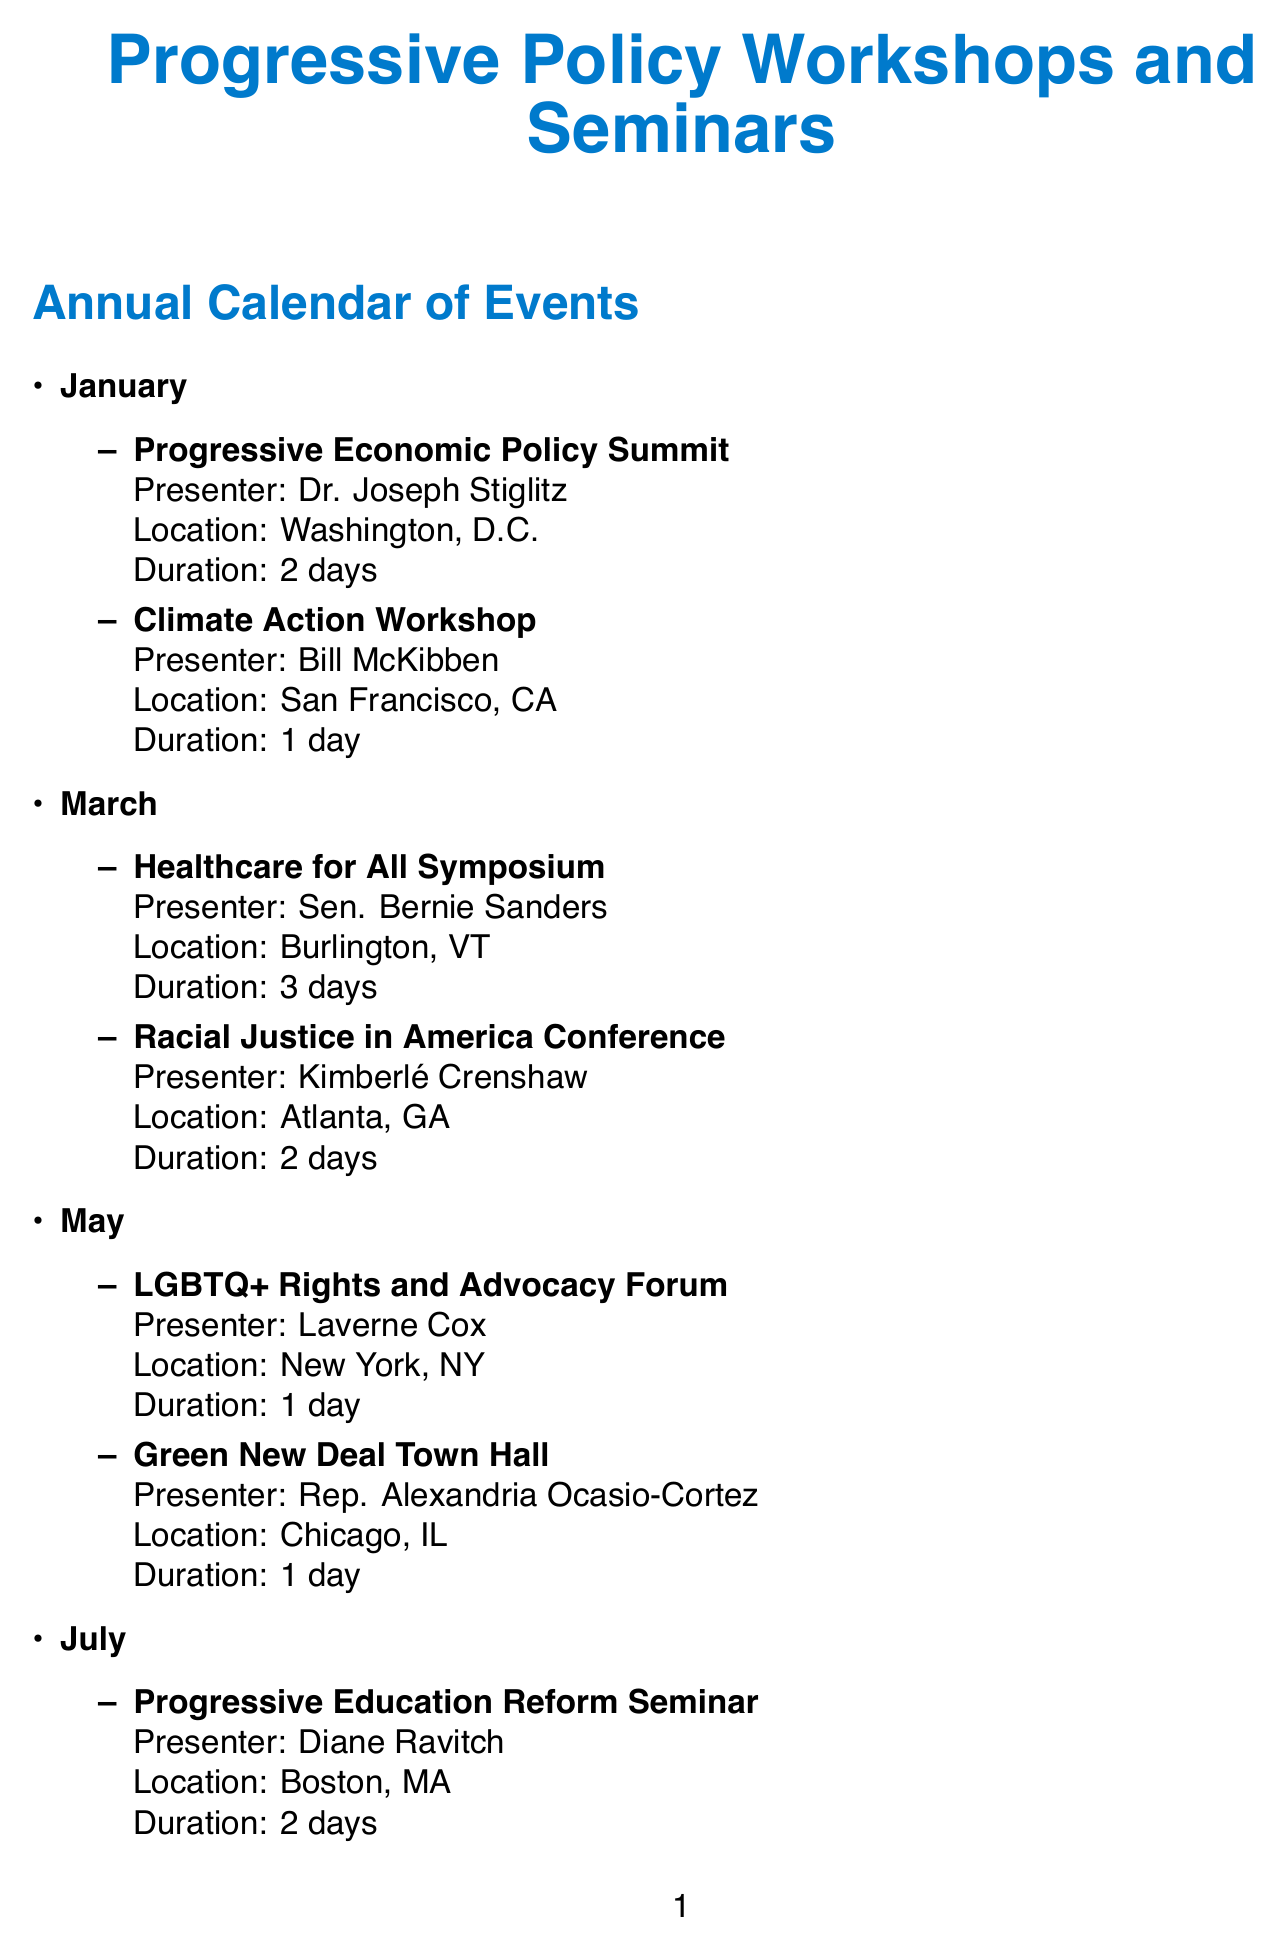What is the name of the presenter for the Climate Action Workshop? The information can be found under the January events section, specifically for the Climate Action Workshop.
Answer: Bill McKibben How long is the Healthcare for All Symposium? This information is provided in the March events listing, detailing the duration of the symposium.
Answer: 3 days Which city hosts the Intersectional Feminism and Gender Equality Summit? This location is specified in the November events section for the Intersectional Feminism and Gender Equality Summit.
Answer: Seattle, WA What is the frequency of the Progressive Policy Network Mixer? This detail is listed under the Networking Opportunities section, providing the frequency of the mixer.
Answer: Monthly How many events are scheduled in September? By counting the entries in the September events section, we can determine the number of events planned for that month.
Answer: 2 Who is the presenter at the Sustainable Agriculture and Food Justice Symposium? The name of the presenter is included in the September events details.
Answer: Vandana Shiva What date does the Annual Progressive Thinkers Retreat occur? The specific date for this retreat is stated in the Networking Opportunities section.
Answer: August 15-17 Which resource is categorized as a weekly publication? This is found in the Resources section that lists various resources available for progressive policy work.
Answer: The Nation magazine 